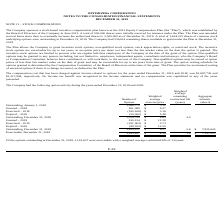According to Optimizerx Corporation's financial document, How much was the aggregate intrinsic value of exercisable options in 2019? According to the financial document, $7,197,053. The relevant text states: "cisable, December 31, 2019 1,143,637 $ 4.39 1.9 $ 7,197,053..." Also, can you calculate: What is the proportion of exercisable options over outstanding options for the year ended in December 31, 2019? Based on the calculation: 1,143,637/1,624,221 , the result is 0.7. This is based on the information: "Exercisable, December 31, 2019 1,143,637 $ 4.39 1.9 $ 7,197,053 to 2,500,000 as of December 31, 2019. A total of 1,624,221 shares of common stock underlying options were outstanding at December 31, 20..." The key data points involved are: 1,143,637, 1,624,221. Also, can you calculate: What is the total price of exercised or expired options during the fiscal year 2019? Based on the calculation: (251,063*3.73)+(89,550*12.55) , the result is 2060317.49. This is based on the information: "Expired – 2019 (89,550) $ 12.55 Exercised – 2019 (251,063) $ 3.73 Exercised – 2019 (251,063) $ 3.73 Expired – 2019 (89,550) $ 12.55..." The key data points involved are: 12.55, 251,063, 3.73. Also, can you calculate: What is the percentage change in the number of shares outstanding at the end of 2018 compared to the start of 2018? To answer this question, I need to perform calculations using the financial data. The calculation is: (1,554,700-1,368,772)/1,368,772 , which equals 13.58 (percentage). This is based on the information: "Outstanding, December 31, 2018 1,554,700 $ 4.63 3.0 Outstanding, January 1, 2018 1,368,772 $ 3.12..." The key data points involved are: 1,368,772, 1,554,700. Also, How much were the compensation costs that have been charged against income related to options in 2018 and 2019, respectively? The document shows two values: $1,317,904 and $1,687,745. From the document: "ded December 31, 2019 and 2018, was $1,687,745 and $1,317,904, respectively. No income tax benefit was recognized in the income statement and no compe..." Also, How many remaining shares are available to grant under the Plan on December 31, 2019? According to the financial document, 236,614. The relevant text states: "outstanding at December 31, 2019. The Company had 236,614 remaining shares available to grant under the Plan at December 31, 2019. The Plan allows the Compan..." 